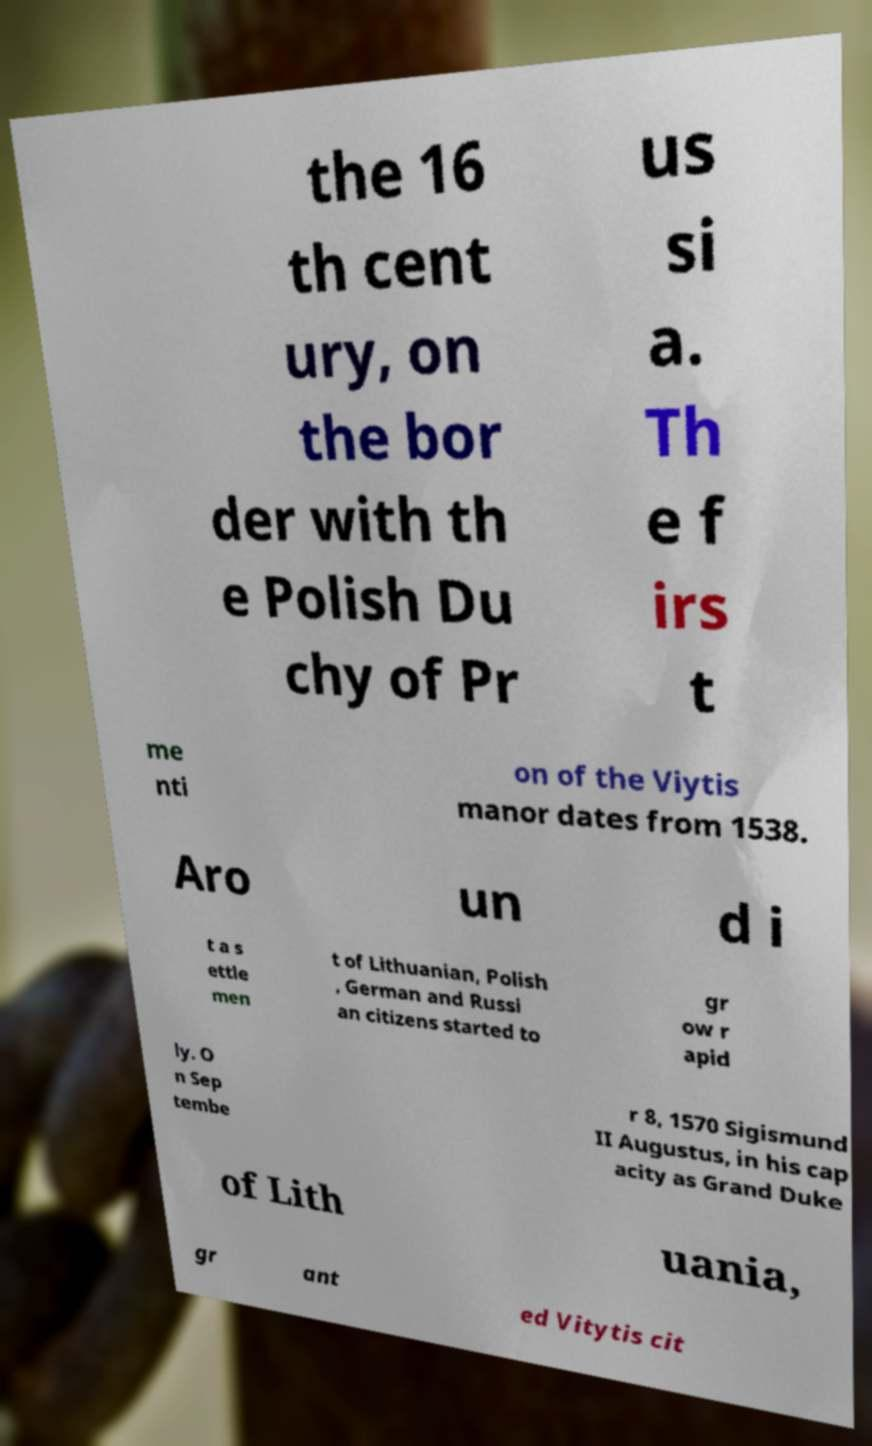Please identify and transcribe the text found in this image. the 16 th cent ury, on the bor der with th e Polish Du chy of Pr us si a. Th e f irs t me nti on of the Viytis manor dates from 1538. Aro un d i t a s ettle men t of Lithuanian, Polish , German and Russi an citizens started to gr ow r apid ly. O n Sep tembe r 8, 1570 Sigismund II Augustus, in his cap acity as Grand Duke of Lith uania, gr ant ed Vitytis cit 